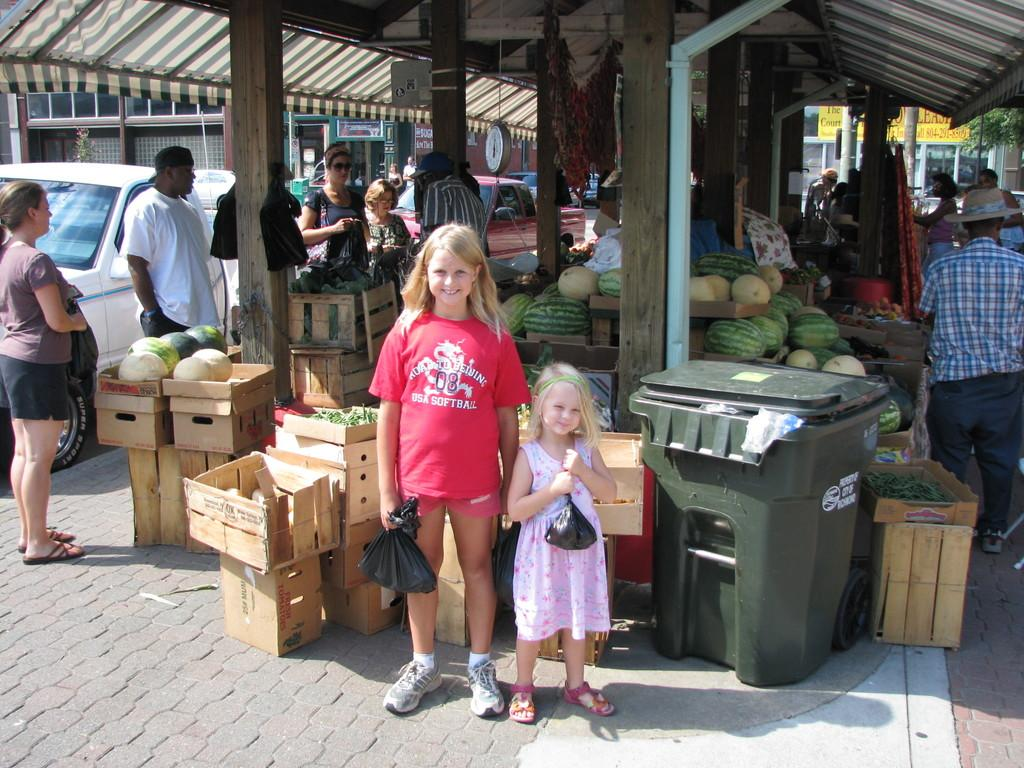<image>
Write a terse but informative summary of the picture. A girl wearing a red softball shirt stands with another girl by a produce market. 